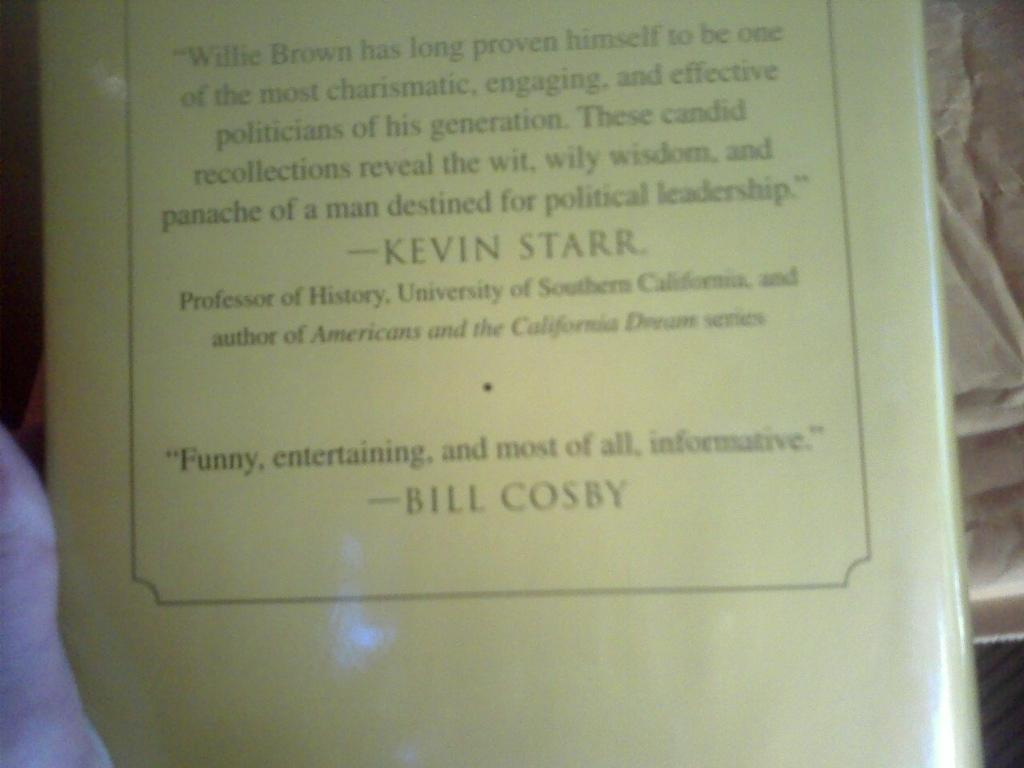<image>
Present a compact description of the photo's key features. the back of a book with reviews from Kevin Starr and Bill Cosby 